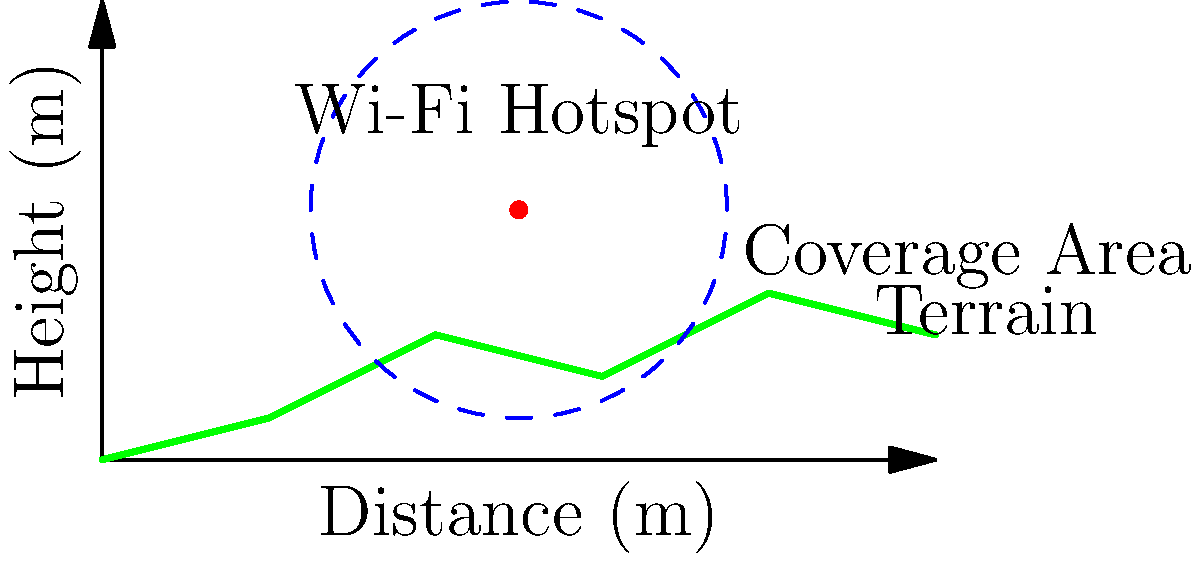As an event planner focusing on rural connectivity, you're tasked with optimizing Wi-Fi coverage for a knowledge-sharing conference in a hilly area. Given a Wi-Fi hotspot with a transmission power of 20 dBm and a receiver sensitivity of -85 dBm, calculate the maximum coverage radius in meters. Assume a path loss exponent of 3.5 due to the terrain and use the simplified path loss formula:

$$ PL = 20 \log_{10}(f) + 10n \log_{10}(d) - 28 $$

Where $f$ is the frequency in MHz (use 2400 MHz for Wi-Fi), $n$ is the path loss exponent, and $d$ is the distance in meters. Round your answer to the nearest meter. To solve this problem, we'll follow these steps:

1) First, we need to calculate the maximum allowable path loss:
   Maximum Path Loss = Transmit Power - Receiver Sensitivity
   $$ PL_{max} = 20 \text{ dBm} - (-85 \text{ dBm}) = 105 \text{ dB} $$

2) Now, we'll use the given path loss formula and solve for $d$:
   $$ 105 = 20 \log_{10}(2400) + 10(3.5) \log_{10}(d) - 28 $$

3) Simplify:
   $$ 105 = 67.6 + 35 \log_{10}(d) - 28 $$
   $$ 65.4 = 35 \log_{10}(d) $$

4) Divide both sides by 35:
   $$ 1.87 = \log_{10}(d) $$

5) Take 10 to the power of both sides:
   $$ 10^{1.87} = d $$

6) Calculate:
   $$ d \approx 74.13 \text{ meters} $$

7) Rounding to the nearest meter:
   $$ d \approx 74 \text{ meters} $$

Therefore, the maximum coverage radius is approximately 74 meters.
Answer: 74 meters 